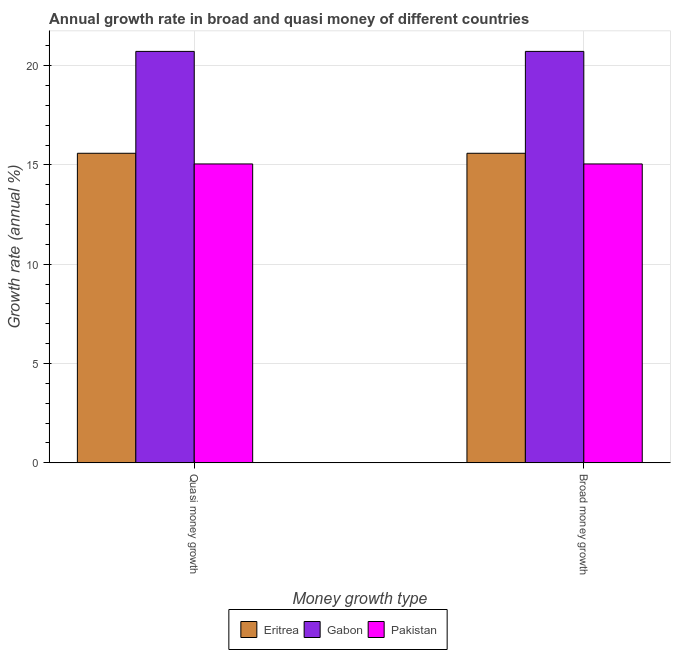How many different coloured bars are there?
Your answer should be very brief. 3. How many groups of bars are there?
Make the answer very short. 2. Are the number of bars per tick equal to the number of legend labels?
Offer a very short reply. Yes. Are the number of bars on each tick of the X-axis equal?
Your answer should be compact. Yes. How many bars are there on the 2nd tick from the left?
Your response must be concise. 3. What is the label of the 1st group of bars from the left?
Offer a terse response. Quasi money growth. What is the annual growth rate in broad money in Pakistan?
Provide a short and direct response. 15.05. Across all countries, what is the maximum annual growth rate in quasi money?
Offer a very short reply. 20.72. Across all countries, what is the minimum annual growth rate in broad money?
Offer a very short reply. 15.05. In which country was the annual growth rate in quasi money maximum?
Give a very brief answer. Gabon. In which country was the annual growth rate in quasi money minimum?
Provide a succinct answer. Pakistan. What is the total annual growth rate in quasi money in the graph?
Your response must be concise. 51.37. What is the difference between the annual growth rate in broad money in Pakistan and that in Eritrea?
Give a very brief answer. -0.54. What is the difference between the annual growth rate in broad money in Eritrea and the annual growth rate in quasi money in Gabon?
Keep it short and to the point. -5.13. What is the average annual growth rate in quasi money per country?
Ensure brevity in your answer.  17.12. In how many countries, is the annual growth rate in broad money greater than 15 %?
Your answer should be compact. 3. What is the ratio of the annual growth rate in broad money in Pakistan to that in Gabon?
Offer a terse response. 0.73. In how many countries, is the annual growth rate in broad money greater than the average annual growth rate in broad money taken over all countries?
Provide a succinct answer. 1. What does the 2nd bar from the left in Quasi money growth represents?
Provide a succinct answer. Gabon. What does the 2nd bar from the right in Quasi money growth represents?
Your answer should be compact. Gabon. Are all the bars in the graph horizontal?
Offer a very short reply. No. Are the values on the major ticks of Y-axis written in scientific E-notation?
Make the answer very short. No. Does the graph contain grids?
Your response must be concise. Yes. What is the title of the graph?
Offer a very short reply. Annual growth rate in broad and quasi money of different countries. What is the label or title of the X-axis?
Your answer should be very brief. Money growth type. What is the label or title of the Y-axis?
Your answer should be compact. Growth rate (annual %). What is the Growth rate (annual %) in Eritrea in Quasi money growth?
Your response must be concise. 15.59. What is the Growth rate (annual %) of Gabon in Quasi money growth?
Give a very brief answer. 20.72. What is the Growth rate (annual %) of Pakistan in Quasi money growth?
Provide a short and direct response. 15.05. What is the Growth rate (annual %) in Eritrea in Broad money growth?
Give a very brief answer. 15.59. What is the Growth rate (annual %) of Gabon in Broad money growth?
Give a very brief answer. 20.72. What is the Growth rate (annual %) in Pakistan in Broad money growth?
Your answer should be very brief. 15.05. Across all Money growth type, what is the maximum Growth rate (annual %) in Eritrea?
Make the answer very short. 15.59. Across all Money growth type, what is the maximum Growth rate (annual %) of Gabon?
Make the answer very short. 20.72. Across all Money growth type, what is the maximum Growth rate (annual %) of Pakistan?
Make the answer very short. 15.05. Across all Money growth type, what is the minimum Growth rate (annual %) in Eritrea?
Offer a terse response. 15.59. Across all Money growth type, what is the minimum Growth rate (annual %) of Gabon?
Your answer should be compact. 20.72. Across all Money growth type, what is the minimum Growth rate (annual %) of Pakistan?
Ensure brevity in your answer.  15.05. What is the total Growth rate (annual %) in Eritrea in the graph?
Keep it short and to the point. 31.18. What is the total Growth rate (annual %) of Gabon in the graph?
Keep it short and to the point. 41.44. What is the total Growth rate (annual %) of Pakistan in the graph?
Provide a succinct answer. 30.11. What is the difference between the Growth rate (annual %) of Pakistan in Quasi money growth and that in Broad money growth?
Your answer should be compact. 0. What is the difference between the Growth rate (annual %) in Eritrea in Quasi money growth and the Growth rate (annual %) in Gabon in Broad money growth?
Make the answer very short. -5.13. What is the difference between the Growth rate (annual %) in Eritrea in Quasi money growth and the Growth rate (annual %) in Pakistan in Broad money growth?
Ensure brevity in your answer.  0.54. What is the difference between the Growth rate (annual %) in Gabon in Quasi money growth and the Growth rate (annual %) in Pakistan in Broad money growth?
Your answer should be compact. 5.67. What is the average Growth rate (annual %) of Eritrea per Money growth type?
Your answer should be compact. 15.59. What is the average Growth rate (annual %) of Gabon per Money growth type?
Offer a terse response. 20.72. What is the average Growth rate (annual %) of Pakistan per Money growth type?
Keep it short and to the point. 15.05. What is the difference between the Growth rate (annual %) in Eritrea and Growth rate (annual %) in Gabon in Quasi money growth?
Your response must be concise. -5.13. What is the difference between the Growth rate (annual %) of Eritrea and Growth rate (annual %) of Pakistan in Quasi money growth?
Your answer should be compact. 0.54. What is the difference between the Growth rate (annual %) in Gabon and Growth rate (annual %) in Pakistan in Quasi money growth?
Ensure brevity in your answer.  5.67. What is the difference between the Growth rate (annual %) of Eritrea and Growth rate (annual %) of Gabon in Broad money growth?
Provide a succinct answer. -5.13. What is the difference between the Growth rate (annual %) in Eritrea and Growth rate (annual %) in Pakistan in Broad money growth?
Your answer should be very brief. 0.54. What is the difference between the Growth rate (annual %) of Gabon and Growth rate (annual %) of Pakistan in Broad money growth?
Offer a terse response. 5.67. What is the ratio of the Growth rate (annual %) of Eritrea in Quasi money growth to that in Broad money growth?
Your answer should be compact. 1. What is the ratio of the Growth rate (annual %) of Gabon in Quasi money growth to that in Broad money growth?
Ensure brevity in your answer.  1. What is the difference between the highest and the second highest Growth rate (annual %) of Eritrea?
Offer a very short reply. 0. What is the difference between the highest and the second highest Growth rate (annual %) in Gabon?
Keep it short and to the point. 0. What is the difference between the highest and the second highest Growth rate (annual %) of Pakistan?
Your answer should be very brief. 0. What is the difference between the highest and the lowest Growth rate (annual %) of Eritrea?
Your answer should be compact. 0. 